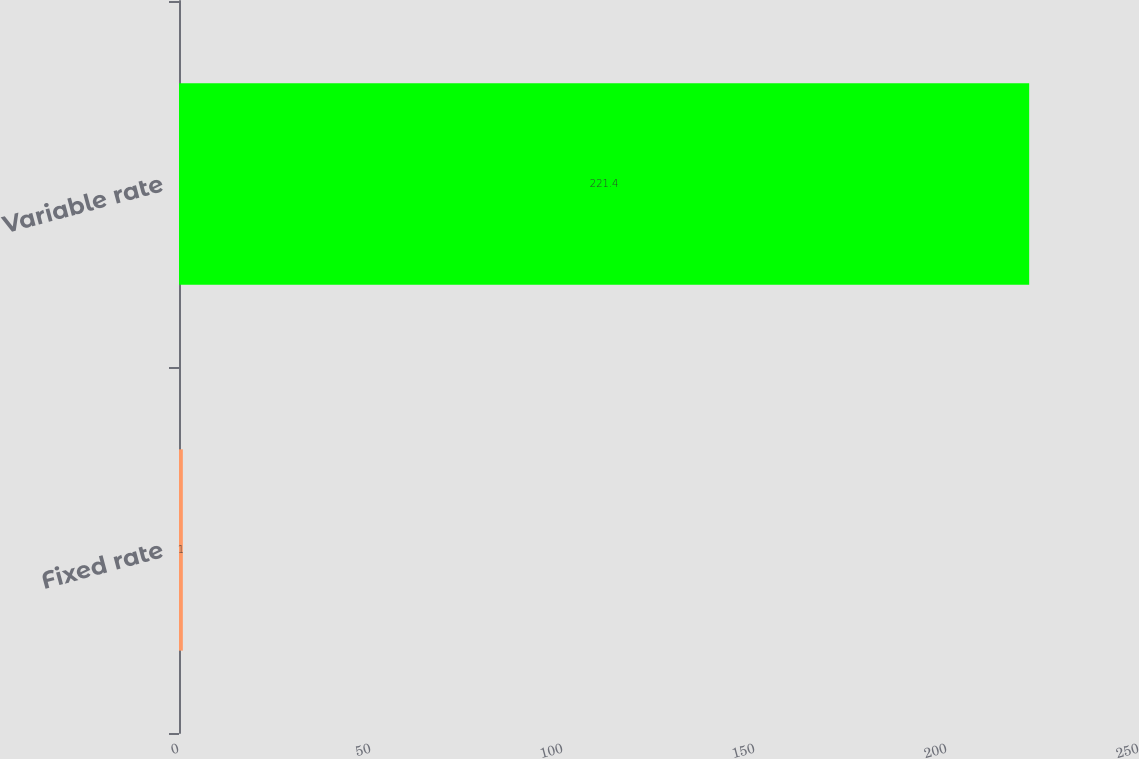Convert chart to OTSL. <chart><loc_0><loc_0><loc_500><loc_500><bar_chart><fcel>Fixed rate<fcel>Variable rate<nl><fcel>1<fcel>221.4<nl></chart> 